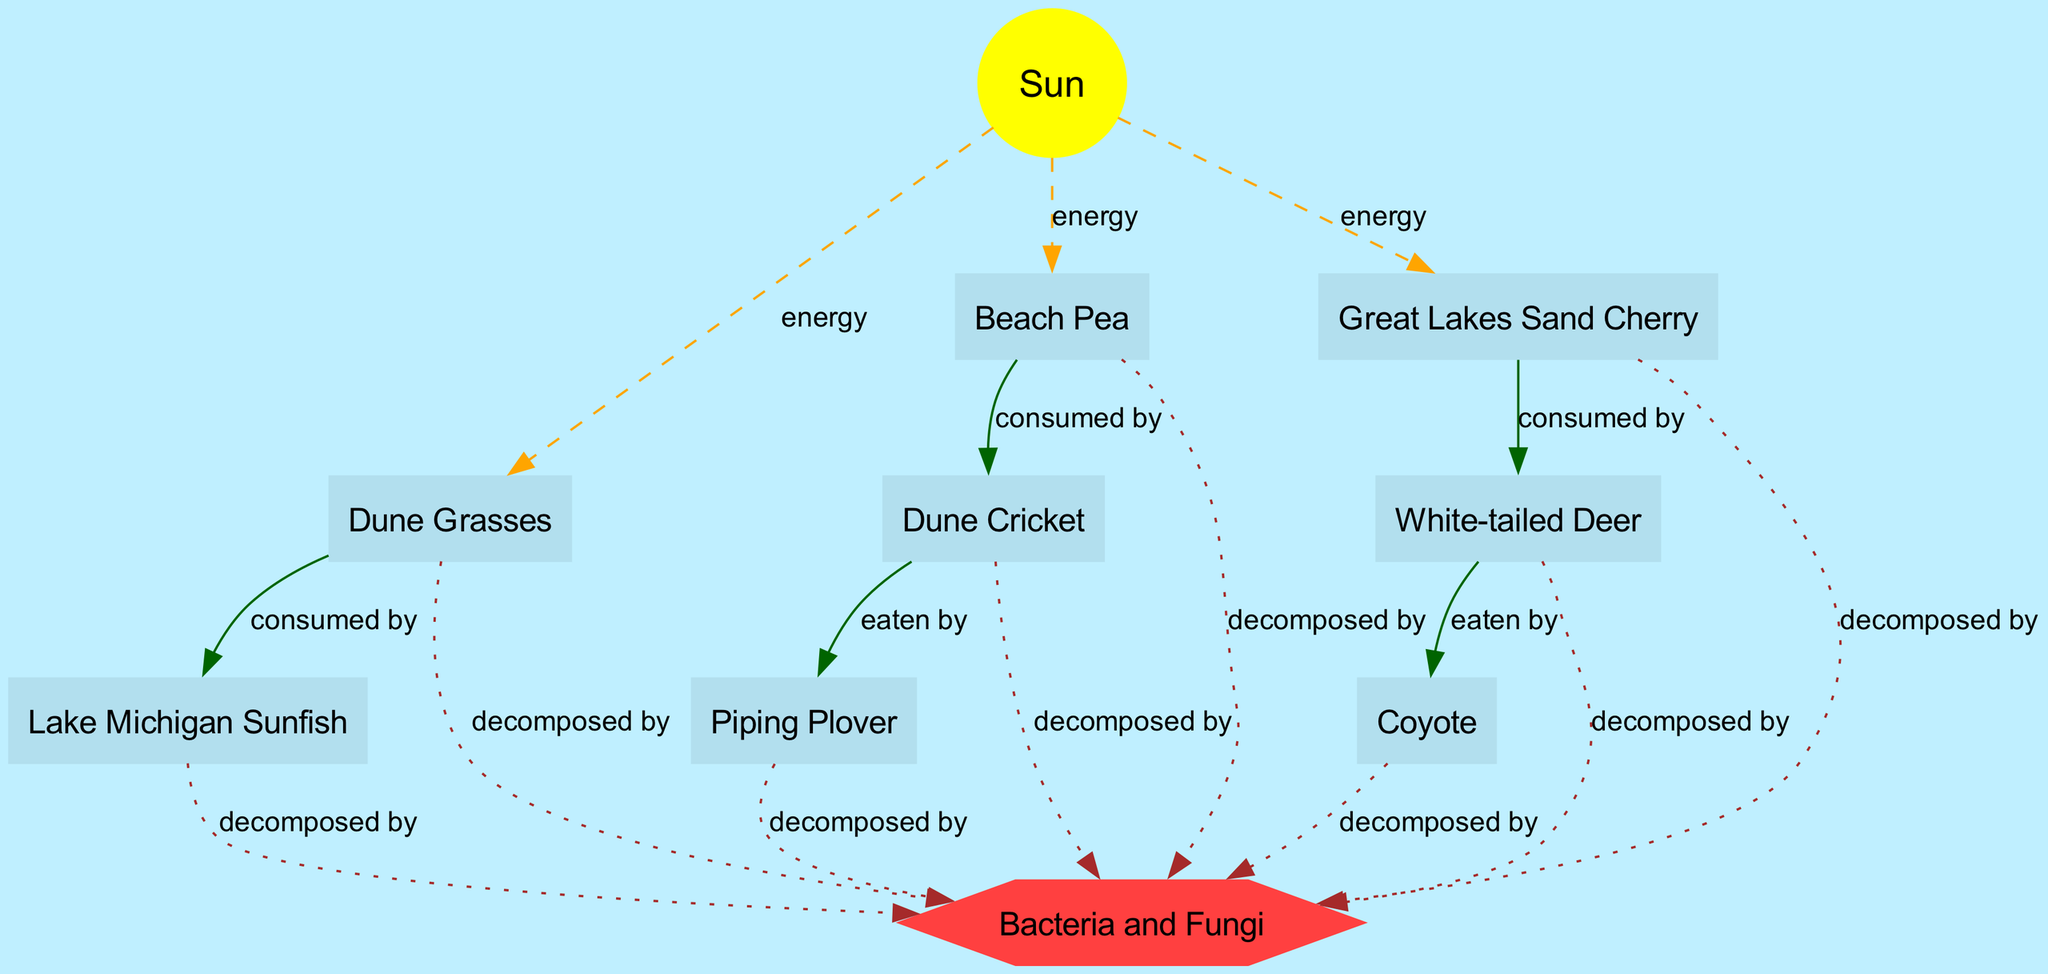What is the energy source for this food chain? The diagram indicates that the primary energy source for the food chain is labeled as "Sun."
Answer: Sun How many organisms are included in the food chain? The diagram lists a total of eight organisms: Lake Michigan Sunfish, Dune Grasses, Beach Pea, Piping Plover, White-tailed Deer, Coyote, Great Lakes Sand Cherry, and Dune Cricket.
Answer: 8 Which organism is eaten by the Piping Plover? In the diagram, the Piping Plover is shown with an edge that indicates it eats the Dune Cricket.
Answer: Dune Cricket What do White-tailed Deer consume? The relationship specified in the diagram shows that White-tailed Deer consume Great Lakes Sand Cherry.
Answer: Great Lakes Sand Cherry What connects the organisms to decomposers? The edges in the diagram connecting all organisms to a node labeled "Decomposers" indicate that these organisms are decomposed by Bacteria and Fungi.
Answer: Bacteria and Fungi Which organism consumes Beach Pea? The diagram shows that the Dune Cricket is the organism that consumes Beach Pea, as indicated by the corresponding edge.
Answer: Dune Cricket What type of diagram is this? The diagram is a directed graph representing a food chain, specifically detailing interactions between organisms in a coastal dune ecosystem.
Answer: Food Chain How does energy flow from the Sun to Dune Grasses? The diagram includes a dashed edge from the Sun to Dune Grasses, indicating that energy from the Sun is provided to the Dune Grasses.
Answer: energy What is the relationship between Coyote and White-tailed Deer? The diagram shows that Coyote preys on (eats) White-tailed Deer, indicated by the corresponding edge labeled "eaten by."
Answer: eaten by 